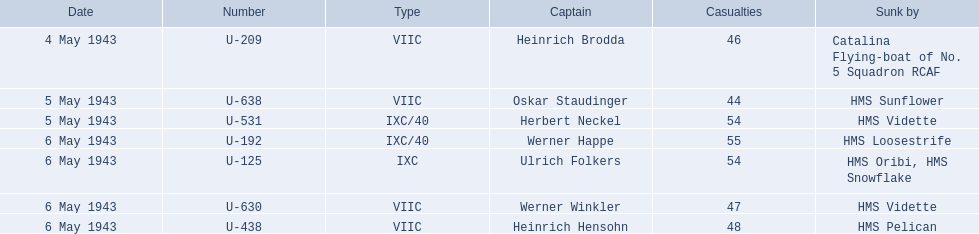What is the inventory of ships taken down by? Catalina Flying-boat of No. 5 Squadron RCAF, HMS Sunflower, HMS Vidette, HMS Loosestrife, HMS Oribi, HMS Snowflake, HMS Vidette, HMS Pelican. Which captains did hms pelican cause to sink? Heinrich Hensohn. 